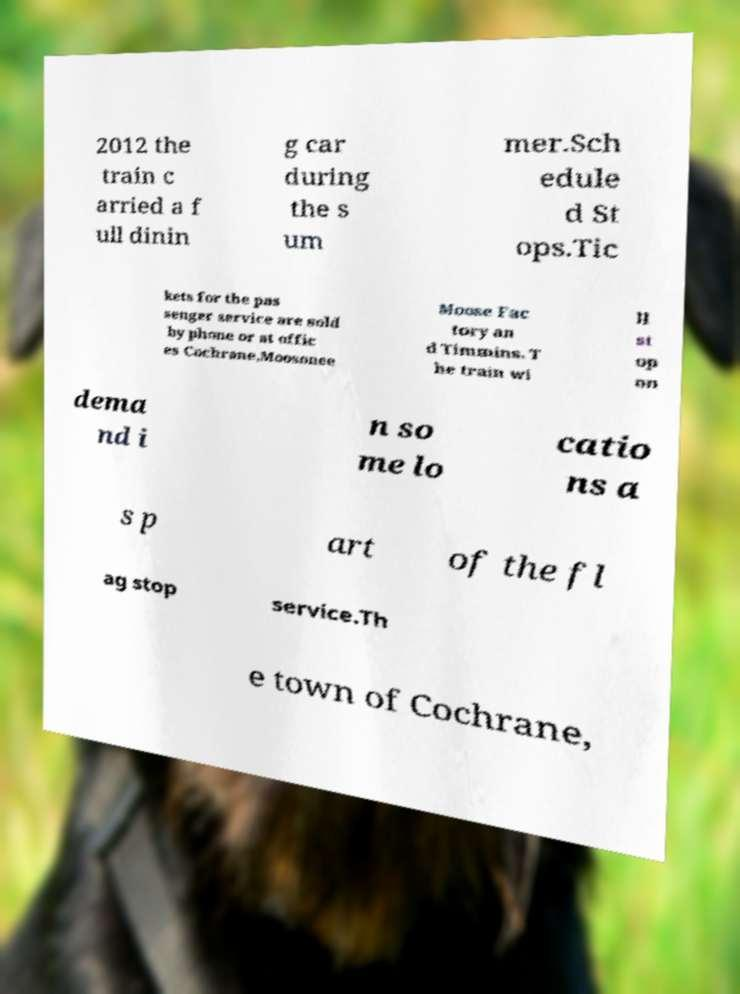Can you accurately transcribe the text from the provided image for me? 2012 the train c arried a f ull dinin g car during the s um mer.Sch edule d St ops.Tic kets for the pas senger service are sold by phone or at offic es Cochrane,Moosonee Moose Fac tory an d Timmins. T he train wi ll st op on dema nd i n so me lo catio ns a s p art of the fl ag stop service.Th e town of Cochrane, 